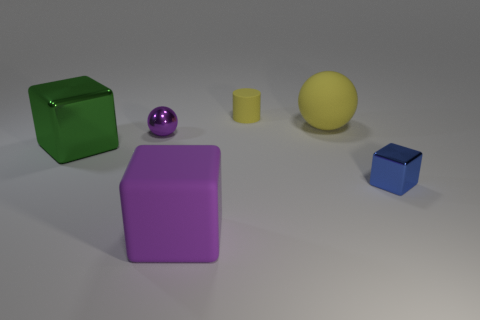What number of green objects are large metal cylinders or cubes?
Ensure brevity in your answer.  1. What is the size of the block that is on the left side of the large matte object in front of the blue shiny block?
Keep it short and to the point. Large. There is a matte sphere; does it have the same color as the small thing behind the purple metallic sphere?
Offer a terse response. Yes. How many other objects are the same material as the small yellow cylinder?
Provide a succinct answer. 2. What is the shape of the tiny purple object that is made of the same material as the big green thing?
Keep it short and to the point. Sphere. Is there any other thing that is the same color as the tiny rubber cylinder?
Give a very brief answer. Yes. There is a object that is the same color as the cylinder; what is its size?
Your answer should be compact. Large. Are there more purple metallic things that are behind the tiny purple shiny object than green blocks?
Provide a succinct answer. No. There is a large yellow rubber object; does it have the same shape as the metallic thing that is right of the large purple rubber block?
Give a very brief answer. No. What number of metallic things are the same size as the purple shiny ball?
Offer a very short reply. 1. 